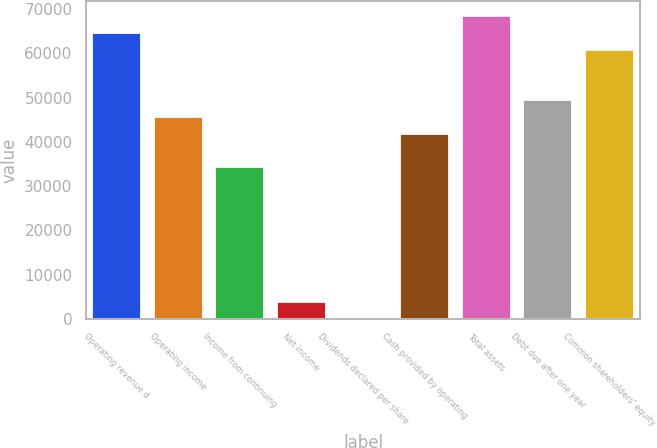<chart> <loc_0><loc_0><loc_500><loc_500><bar_chart><fcel>Operating revenue d<fcel>Operating income<fcel>Income from continuing<fcel>Net income<fcel>Dividends declared per share<fcel>Cash provided by operating<fcel>Total assets<fcel>Debt due after one year<fcel>Common shareholders' equity<nl><fcel>64655<fcel>45639.3<fcel>34229.8<fcel>3804.64<fcel>1.49<fcel>41836.1<fcel>68458.2<fcel>49442.4<fcel>60851.9<nl></chart> 